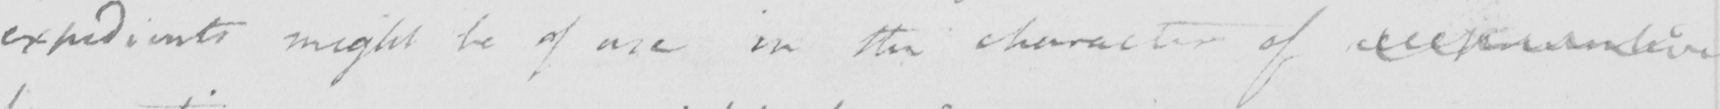Please transcribe the handwritten text in this image. expedients might be of use in the character of <gap/> 